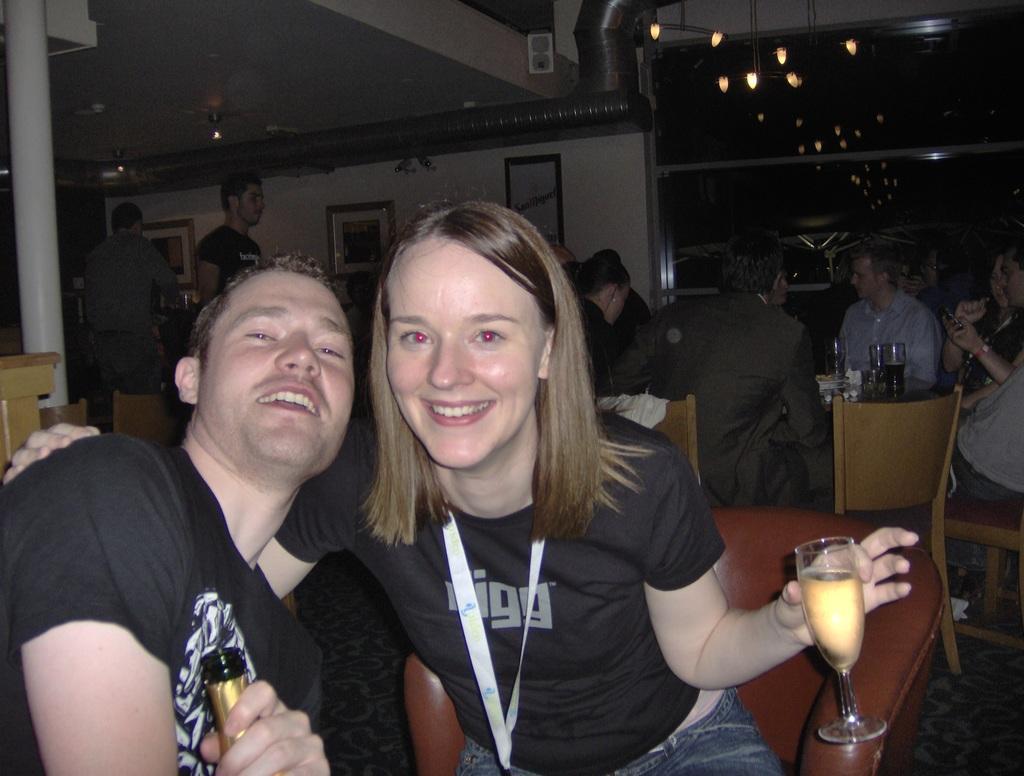Please provide a concise description of this image. The men in the left corner is sitting and holding a wine bottle in his hand and there is another woman sitting beside him is holding a glass of wine in her hand and there are few persons behind them. 